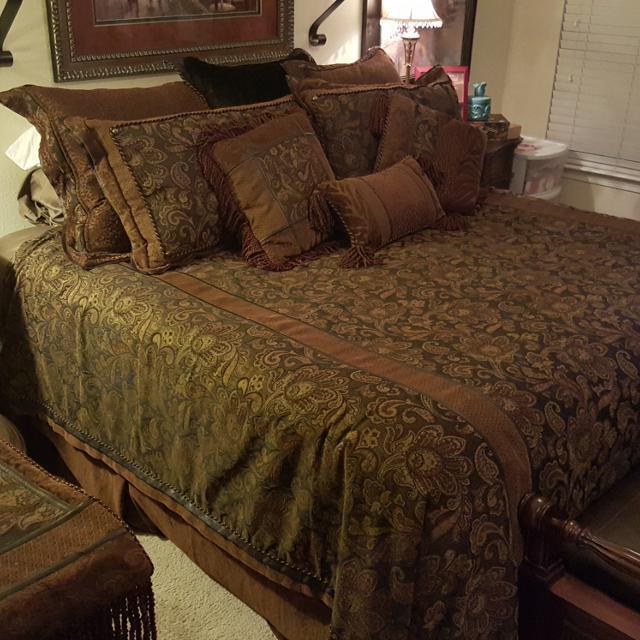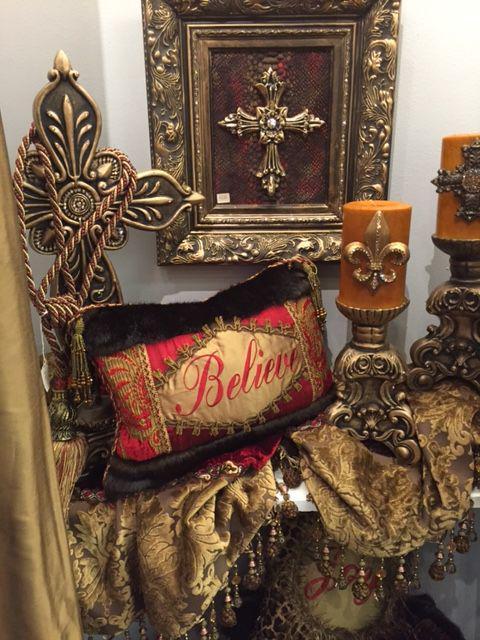The first image is the image on the left, the second image is the image on the right. Examine the images to the left and right. Is the description "In at least one image, no framed wall art is displayed in the bedroom." accurate? Answer yes or no. No. 